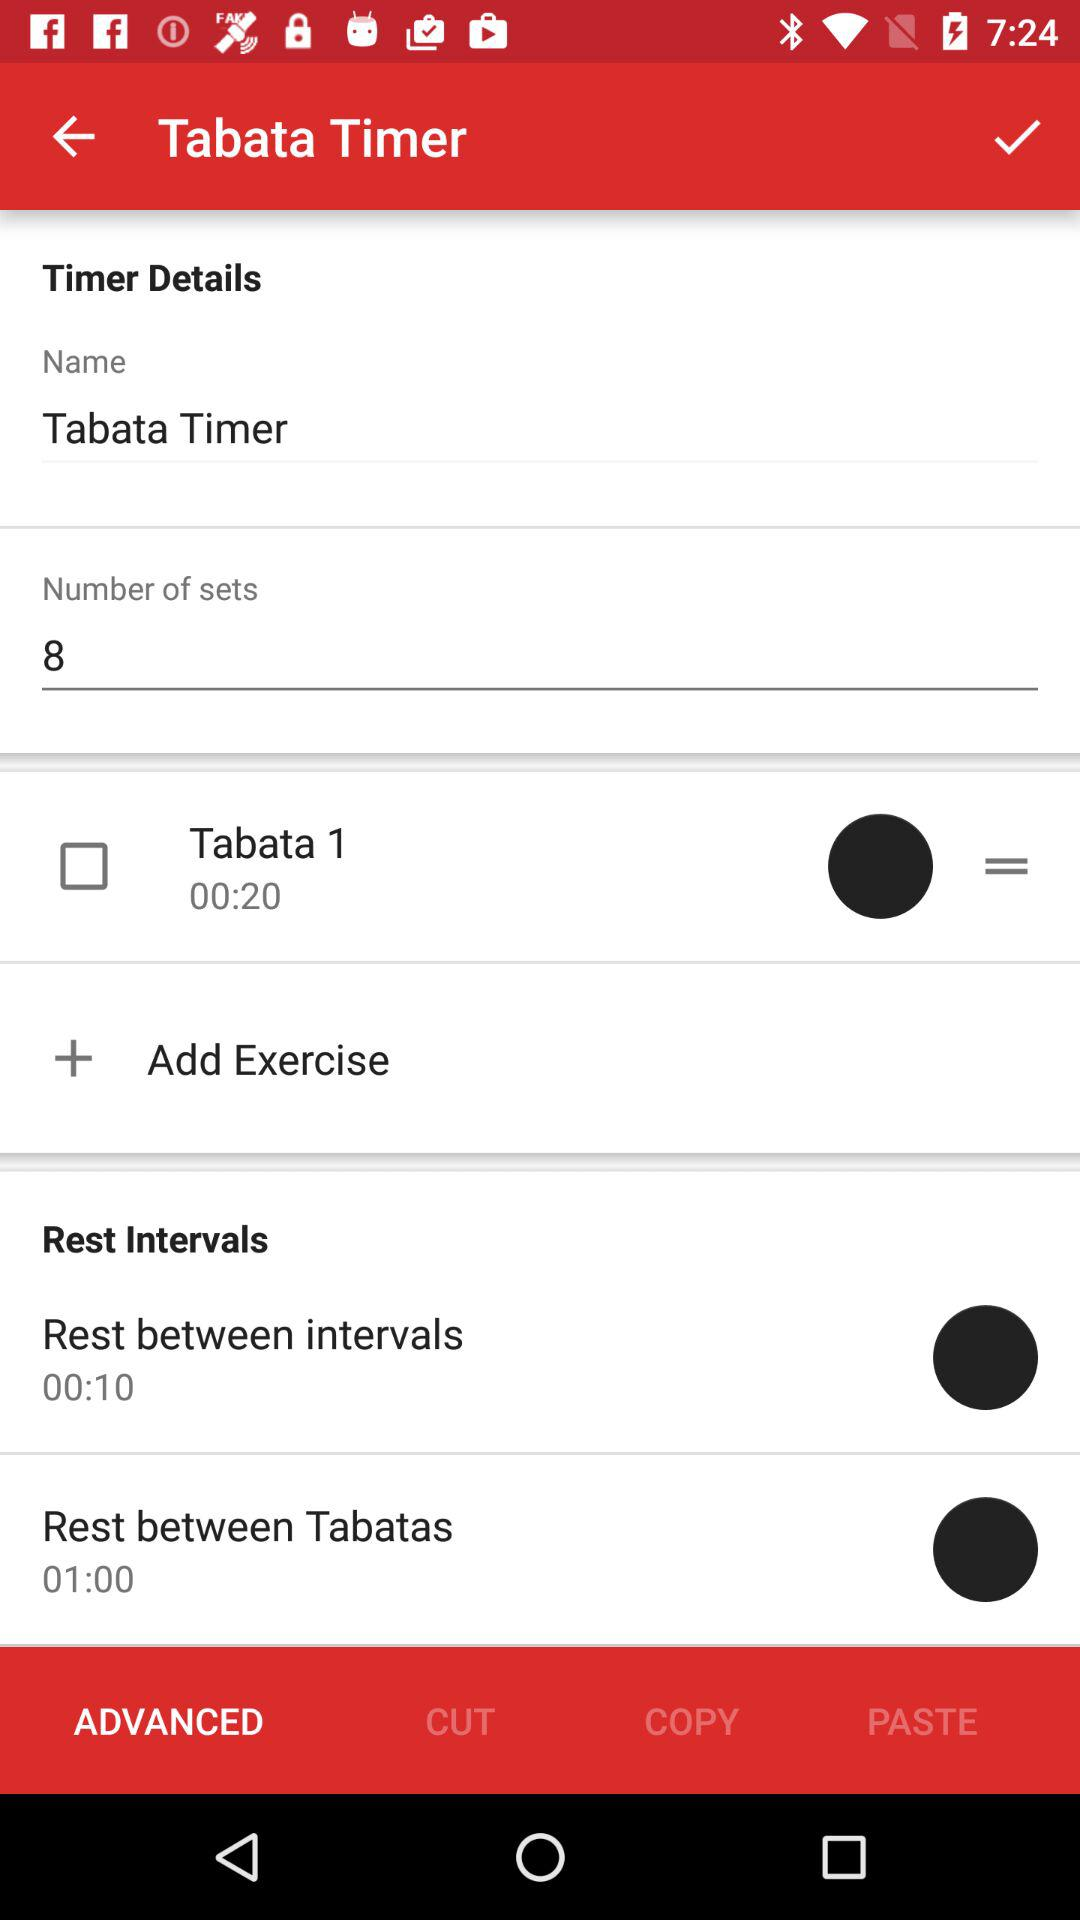What is the application name? The application name is "Tabata Timer". 